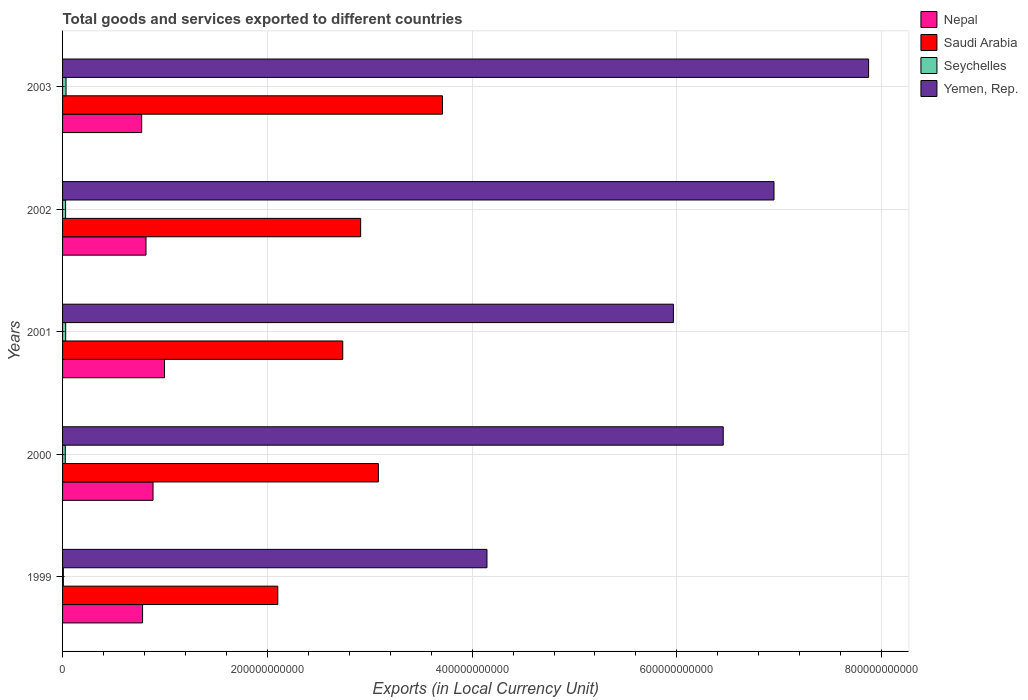Are the number of bars on each tick of the Y-axis equal?
Offer a very short reply. Yes. How many bars are there on the 3rd tick from the top?
Give a very brief answer. 4. In how many cases, is the number of bars for a given year not equal to the number of legend labels?
Keep it short and to the point. 0. What is the Amount of goods and services exports in Seychelles in 2001?
Keep it short and to the point. 3.05e+09. Across all years, what is the maximum Amount of goods and services exports in Seychelles?
Provide a short and direct response. 3.39e+09. Across all years, what is the minimum Amount of goods and services exports in Saudi Arabia?
Give a very brief answer. 2.10e+11. In which year was the Amount of goods and services exports in Saudi Arabia minimum?
Offer a very short reply. 1999. What is the total Amount of goods and services exports in Saudi Arabia in the graph?
Give a very brief answer. 1.45e+12. What is the difference between the Amount of goods and services exports in Saudi Arabia in 2000 and that in 2002?
Ensure brevity in your answer.  1.73e+1. What is the difference between the Amount of goods and services exports in Yemen, Rep. in 1999 and the Amount of goods and services exports in Saudi Arabia in 2003?
Make the answer very short. 4.35e+1. What is the average Amount of goods and services exports in Yemen, Rep. per year?
Your answer should be very brief. 6.28e+11. In the year 1999, what is the difference between the Amount of goods and services exports in Yemen, Rep. and Amount of goods and services exports in Saudi Arabia?
Your answer should be very brief. 2.04e+11. What is the ratio of the Amount of goods and services exports in Yemen, Rep. in 2000 to that in 2003?
Offer a terse response. 0.82. Is the Amount of goods and services exports in Saudi Arabia in 2001 less than that in 2002?
Provide a succinct answer. Yes. What is the difference between the highest and the second highest Amount of goods and services exports in Yemen, Rep.?
Offer a terse response. 9.24e+1. What is the difference between the highest and the lowest Amount of goods and services exports in Yemen, Rep.?
Your answer should be very brief. 3.73e+11. What does the 3rd bar from the top in 2003 represents?
Your answer should be compact. Saudi Arabia. What does the 2nd bar from the bottom in 2002 represents?
Your response must be concise. Saudi Arabia. Is it the case that in every year, the sum of the Amount of goods and services exports in Yemen, Rep. and Amount of goods and services exports in Nepal is greater than the Amount of goods and services exports in Seychelles?
Offer a very short reply. Yes. What is the difference between two consecutive major ticks on the X-axis?
Make the answer very short. 2.00e+11. Does the graph contain grids?
Keep it short and to the point. Yes. How many legend labels are there?
Give a very brief answer. 4. What is the title of the graph?
Your answer should be very brief. Total goods and services exported to different countries. What is the label or title of the X-axis?
Ensure brevity in your answer.  Exports (in Local Currency Unit). What is the Exports (in Local Currency Unit) of Nepal in 1999?
Your answer should be compact. 7.82e+1. What is the Exports (in Local Currency Unit) of Saudi Arabia in 1999?
Make the answer very short. 2.10e+11. What is the Exports (in Local Currency Unit) in Seychelles in 1999?
Provide a short and direct response. 7.75e+08. What is the Exports (in Local Currency Unit) of Yemen, Rep. in 1999?
Offer a very short reply. 4.15e+11. What is the Exports (in Local Currency Unit) in Nepal in 2000?
Keep it short and to the point. 8.84e+1. What is the Exports (in Local Currency Unit) of Saudi Arabia in 2000?
Keep it short and to the point. 3.08e+11. What is the Exports (in Local Currency Unit) of Seychelles in 2000?
Keep it short and to the point. 2.65e+09. What is the Exports (in Local Currency Unit) of Yemen, Rep. in 2000?
Your answer should be very brief. 6.45e+11. What is the Exports (in Local Currency Unit) in Nepal in 2001?
Your response must be concise. 9.96e+1. What is the Exports (in Local Currency Unit) of Saudi Arabia in 2001?
Give a very brief answer. 2.74e+11. What is the Exports (in Local Currency Unit) of Seychelles in 2001?
Your answer should be very brief. 3.05e+09. What is the Exports (in Local Currency Unit) of Yemen, Rep. in 2001?
Your answer should be compact. 5.97e+11. What is the Exports (in Local Currency Unit) of Nepal in 2002?
Ensure brevity in your answer.  8.15e+1. What is the Exports (in Local Currency Unit) in Saudi Arabia in 2002?
Offer a very short reply. 2.91e+11. What is the Exports (in Local Currency Unit) of Seychelles in 2002?
Provide a succinct answer. 2.98e+09. What is the Exports (in Local Currency Unit) in Yemen, Rep. in 2002?
Your answer should be very brief. 6.95e+11. What is the Exports (in Local Currency Unit) in Nepal in 2003?
Your answer should be compact. 7.73e+1. What is the Exports (in Local Currency Unit) of Saudi Arabia in 2003?
Provide a succinct answer. 3.71e+11. What is the Exports (in Local Currency Unit) of Seychelles in 2003?
Provide a succinct answer. 3.39e+09. What is the Exports (in Local Currency Unit) in Yemen, Rep. in 2003?
Offer a terse response. 7.87e+11. Across all years, what is the maximum Exports (in Local Currency Unit) in Nepal?
Your answer should be compact. 9.96e+1. Across all years, what is the maximum Exports (in Local Currency Unit) in Saudi Arabia?
Keep it short and to the point. 3.71e+11. Across all years, what is the maximum Exports (in Local Currency Unit) of Seychelles?
Provide a short and direct response. 3.39e+09. Across all years, what is the maximum Exports (in Local Currency Unit) of Yemen, Rep.?
Ensure brevity in your answer.  7.87e+11. Across all years, what is the minimum Exports (in Local Currency Unit) in Nepal?
Your response must be concise. 7.73e+1. Across all years, what is the minimum Exports (in Local Currency Unit) of Saudi Arabia?
Make the answer very short. 2.10e+11. Across all years, what is the minimum Exports (in Local Currency Unit) in Seychelles?
Your answer should be very brief. 7.75e+08. Across all years, what is the minimum Exports (in Local Currency Unit) of Yemen, Rep.?
Keep it short and to the point. 4.15e+11. What is the total Exports (in Local Currency Unit) of Nepal in the graph?
Give a very brief answer. 4.25e+11. What is the total Exports (in Local Currency Unit) of Saudi Arabia in the graph?
Provide a succinct answer. 1.45e+12. What is the total Exports (in Local Currency Unit) of Seychelles in the graph?
Provide a succinct answer. 1.28e+1. What is the total Exports (in Local Currency Unit) in Yemen, Rep. in the graph?
Your response must be concise. 3.14e+12. What is the difference between the Exports (in Local Currency Unit) of Nepal in 1999 and that in 2000?
Your response must be concise. -1.02e+1. What is the difference between the Exports (in Local Currency Unit) of Saudi Arabia in 1999 and that in 2000?
Your response must be concise. -9.82e+1. What is the difference between the Exports (in Local Currency Unit) in Seychelles in 1999 and that in 2000?
Keep it short and to the point. -1.88e+09. What is the difference between the Exports (in Local Currency Unit) in Yemen, Rep. in 1999 and that in 2000?
Keep it short and to the point. -2.31e+11. What is the difference between the Exports (in Local Currency Unit) in Nepal in 1999 and that in 2001?
Offer a very short reply. -2.14e+1. What is the difference between the Exports (in Local Currency Unit) of Saudi Arabia in 1999 and that in 2001?
Provide a succinct answer. -6.34e+1. What is the difference between the Exports (in Local Currency Unit) in Seychelles in 1999 and that in 2001?
Provide a short and direct response. -2.28e+09. What is the difference between the Exports (in Local Currency Unit) of Yemen, Rep. in 1999 and that in 2001?
Offer a terse response. -1.82e+11. What is the difference between the Exports (in Local Currency Unit) in Nepal in 1999 and that in 2002?
Offer a terse response. -3.34e+09. What is the difference between the Exports (in Local Currency Unit) of Saudi Arabia in 1999 and that in 2002?
Your answer should be very brief. -8.09e+1. What is the difference between the Exports (in Local Currency Unit) of Seychelles in 1999 and that in 2002?
Your answer should be very brief. -2.20e+09. What is the difference between the Exports (in Local Currency Unit) in Yemen, Rep. in 1999 and that in 2002?
Provide a succinct answer. -2.80e+11. What is the difference between the Exports (in Local Currency Unit) in Nepal in 1999 and that in 2003?
Ensure brevity in your answer.  8.70e+08. What is the difference between the Exports (in Local Currency Unit) in Saudi Arabia in 1999 and that in 2003?
Offer a very short reply. -1.61e+11. What is the difference between the Exports (in Local Currency Unit) in Seychelles in 1999 and that in 2003?
Provide a short and direct response. -2.61e+09. What is the difference between the Exports (in Local Currency Unit) in Yemen, Rep. in 1999 and that in 2003?
Your answer should be compact. -3.73e+11. What is the difference between the Exports (in Local Currency Unit) in Nepal in 2000 and that in 2001?
Offer a very short reply. -1.12e+1. What is the difference between the Exports (in Local Currency Unit) in Saudi Arabia in 2000 and that in 2001?
Offer a very short reply. 3.48e+1. What is the difference between the Exports (in Local Currency Unit) in Seychelles in 2000 and that in 2001?
Offer a terse response. -4.03e+08. What is the difference between the Exports (in Local Currency Unit) of Yemen, Rep. in 2000 and that in 2001?
Offer a very short reply. 4.87e+1. What is the difference between the Exports (in Local Currency Unit) of Nepal in 2000 and that in 2002?
Your answer should be compact. 6.87e+09. What is the difference between the Exports (in Local Currency Unit) in Saudi Arabia in 2000 and that in 2002?
Your answer should be compact. 1.73e+1. What is the difference between the Exports (in Local Currency Unit) of Seychelles in 2000 and that in 2002?
Give a very brief answer. -3.25e+08. What is the difference between the Exports (in Local Currency Unit) of Yemen, Rep. in 2000 and that in 2002?
Your answer should be compact. -4.96e+1. What is the difference between the Exports (in Local Currency Unit) in Nepal in 2000 and that in 2003?
Ensure brevity in your answer.  1.11e+1. What is the difference between the Exports (in Local Currency Unit) of Saudi Arabia in 2000 and that in 2003?
Your response must be concise. -6.26e+1. What is the difference between the Exports (in Local Currency Unit) of Seychelles in 2000 and that in 2003?
Offer a terse response. -7.36e+08. What is the difference between the Exports (in Local Currency Unit) of Yemen, Rep. in 2000 and that in 2003?
Keep it short and to the point. -1.42e+11. What is the difference between the Exports (in Local Currency Unit) in Nepal in 2001 and that in 2002?
Give a very brief answer. 1.81e+1. What is the difference between the Exports (in Local Currency Unit) of Saudi Arabia in 2001 and that in 2002?
Keep it short and to the point. -1.75e+1. What is the difference between the Exports (in Local Currency Unit) of Seychelles in 2001 and that in 2002?
Make the answer very short. 7.77e+07. What is the difference between the Exports (in Local Currency Unit) in Yemen, Rep. in 2001 and that in 2002?
Provide a succinct answer. -9.82e+1. What is the difference between the Exports (in Local Currency Unit) of Nepal in 2001 and that in 2003?
Provide a short and direct response. 2.23e+1. What is the difference between the Exports (in Local Currency Unit) of Saudi Arabia in 2001 and that in 2003?
Your answer should be very brief. -9.74e+1. What is the difference between the Exports (in Local Currency Unit) in Seychelles in 2001 and that in 2003?
Your answer should be very brief. -3.34e+08. What is the difference between the Exports (in Local Currency Unit) of Yemen, Rep. in 2001 and that in 2003?
Offer a terse response. -1.91e+11. What is the difference between the Exports (in Local Currency Unit) of Nepal in 2002 and that in 2003?
Your answer should be very brief. 4.21e+09. What is the difference between the Exports (in Local Currency Unit) of Saudi Arabia in 2002 and that in 2003?
Offer a very short reply. -7.99e+1. What is the difference between the Exports (in Local Currency Unit) in Seychelles in 2002 and that in 2003?
Offer a very short reply. -4.11e+08. What is the difference between the Exports (in Local Currency Unit) in Yemen, Rep. in 2002 and that in 2003?
Ensure brevity in your answer.  -9.24e+1. What is the difference between the Exports (in Local Currency Unit) of Nepal in 1999 and the Exports (in Local Currency Unit) of Saudi Arabia in 2000?
Your answer should be compact. -2.30e+11. What is the difference between the Exports (in Local Currency Unit) in Nepal in 1999 and the Exports (in Local Currency Unit) in Seychelles in 2000?
Provide a succinct answer. 7.55e+1. What is the difference between the Exports (in Local Currency Unit) of Nepal in 1999 and the Exports (in Local Currency Unit) of Yemen, Rep. in 2000?
Give a very brief answer. -5.67e+11. What is the difference between the Exports (in Local Currency Unit) of Saudi Arabia in 1999 and the Exports (in Local Currency Unit) of Seychelles in 2000?
Give a very brief answer. 2.08e+11. What is the difference between the Exports (in Local Currency Unit) of Saudi Arabia in 1999 and the Exports (in Local Currency Unit) of Yemen, Rep. in 2000?
Offer a terse response. -4.35e+11. What is the difference between the Exports (in Local Currency Unit) of Seychelles in 1999 and the Exports (in Local Currency Unit) of Yemen, Rep. in 2000?
Give a very brief answer. -6.45e+11. What is the difference between the Exports (in Local Currency Unit) of Nepal in 1999 and the Exports (in Local Currency Unit) of Saudi Arabia in 2001?
Your response must be concise. -1.96e+11. What is the difference between the Exports (in Local Currency Unit) of Nepal in 1999 and the Exports (in Local Currency Unit) of Seychelles in 2001?
Your answer should be very brief. 7.51e+1. What is the difference between the Exports (in Local Currency Unit) of Nepal in 1999 and the Exports (in Local Currency Unit) of Yemen, Rep. in 2001?
Your answer should be very brief. -5.18e+11. What is the difference between the Exports (in Local Currency Unit) of Saudi Arabia in 1999 and the Exports (in Local Currency Unit) of Seychelles in 2001?
Provide a succinct answer. 2.07e+11. What is the difference between the Exports (in Local Currency Unit) of Saudi Arabia in 1999 and the Exports (in Local Currency Unit) of Yemen, Rep. in 2001?
Keep it short and to the point. -3.86e+11. What is the difference between the Exports (in Local Currency Unit) in Seychelles in 1999 and the Exports (in Local Currency Unit) in Yemen, Rep. in 2001?
Your answer should be compact. -5.96e+11. What is the difference between the Exports (in Local Currency Unit) in Nepal in 1999 and the Exports (in Local Currency Unit) in Saudi Arabia in 2002?
Ensure brevity in your answer.  -2.13e+11. What is the difference between the Exports (in Local Currency Unit) in Nepal in 1999 and the Exports (in Local Currency Unit) in Seychelles in 2002?
Offer a very short reply. 7.52e+1. What is the difference between the Exports (in Local Currency Unit) in Nepal in 1999 and the Exports (in Local Currency Unit) in Yemen, Rep. in 2002?
Provide a succinct answer. -6.17e+11. What is the difference between the Exports (in Local Currency Unit) of Saudi Arabia in 1999 and the Exports (in Local Currency Unit) of Seychelles in 2002?
Keep it short and to the point. 2.07e+11. What is the difference between the Exports (in Local Currency Unit) in Saudi Arabia in 1999 and the Exports (in Local Currency Unit) in Yemen, Rep. in 2002?
Ensure brevity in your answer.  -4.85e+11. What is the difference between the Exports (in Local Currency Unit) in Seychelles in 1999 and the Exports (in Local Currency Unit) in Yemen, Rep. in 2002?
Make the answer very short. -6.94e+11. What is the difference between the Exports (in Local Currency Unit) in Nepal in 1999 and the Exports (in Local Currency Unit) in Saudi Arabia in 2003?
Your response must be concise. -2.93e+11. What is the difference between the Exports (in Local Currency Unit) of Nepal in 1999 and the Exports (in Local Currency Unit) of Seychelles in 2003?
Your response must be concise. 7.48e+1. What is the difference between the Exports (in Local Currency Unit) in Nepal in 1999 and the Exports (in Local Currency Unit) in Yemen, Rep. in 2003?
Offer a very short reply. -7.09e+11. What is the difference between the Exports (in Local Currency Unit) of Saudi Arabia in 1999 and the Exports (in Local Currency Unit) of Seychelles in 2003?
Your response must be concise. 2.07e+11. What is the difference between the Exports (in Local Currency Unit) of Saudi Arabia in 1999 and the Exports (in Local Currency Unit) of Yemen, Rep. in 2003?
Offer a very short reply. -5.77e+11. What is the difference between the Exports (in Local Currency Unit) of Seychelles in 1999 and the Exports (in Local Currency Unit) of Yemen, Rep. in 2003?
Provide a succinct answer. -7.87e+11. What is the difference between the Exports (in Local Currency Unit) of Nepal in 2000 and the Exports (in Local Currency Unit) of Saudi Arabia in 2001?
Your answer should be compact. -1.85e+11. What is the difference between the Exports (in Local Currency Unit) of Nepal in 2000 and the Exports (in Local Currency Unit) of Seychelles in 2001?
Provide a succinct answer. 8.53e+1. What is the difference between the Exports (in Local Currency Unit) in Nepal in 2000 and the Exports (in Local Currency Unit) in Yemen, Rep. in 2001?
Your answer should be compact. -5.08e+11. What is the difference between the Exports (in Local Currency Unit) of Saudi Arabia in 2000 and the Exports (in Local Currency Unit) of Seychelles in 2001?
Provide a short and direct response. 3.05e+11. What is the difference between the Exports (in Local Currency Unit) of Saudi Arabia in 2000 and the Exports (in Local Currency Unit) of Yemen, Rep. in 2001?
Your answer should be very brief. -2.88e+11. What is the difference between the Exports (in Local Currency Unit) of Seychelles in 2000 and the Exports (in Local Currency Unit) of Yemen, Rep. in 2001?
Give a very brief answer. -5.94e+11. What is the difference between the Exports (in Local Currency Unit) of Nepal in 2000 and the Exports (in Local Currency Unit) of Saudi Arabia in 2002?
Your response must be concise. -2.03e+11. What is the difference between the Exports (in Local Currency Unit) in Nepal in 2000 and the Exports (in Local Currency Unit) in Seychelles in 2002?
Provide a short and direct response. 8.54e+1. What is the difference between the Exports (in Local Currency Unit) in Nepal in 2000 and the Exports (in Local Currency Unit) in Yemen, Rep. in 2002?
Provide a succinct answer. -6.07e+11. What is the difference between the Exports (in Local Currency Unit) in Saudi Arabia in 2000 and the Exports (in Local Currency Unit) in Seychelles in 2002?
Your answer should be compact. 3.05e+11. What is the difference between the Exports (in Local Currency Unit) of Saudi Arabia in 2000 and the Exports (in Local Currency Unit) of Yemen, Rep. in 2002?
Give a very brief answer. -3.86e+11. What is the difference between the Exports (in Local Currency Unit) of Seychelles in 2000 and the Exports (in Local Currency Unit) of Yemen, Rep. in 2002?
Offer a very short reply. -6.92e+11. What is the difference between the Exports (in Local Currency Unit) of Nepal in 2000 and the Exports (in Local Currency Unit) of Saudi Arabia in 2003?
Provide a succinct answer. -2.83e+11. What is the difference between the Exports (in Local Currency Unit) in Nepal in 2000 and the Exports (in Local Currency Unit) in Seychelles in 2003?
Your answer should be compact. 8.50e+1. What is the difference between the Exports (in Local Currency Unit) in Nepal in 2000 and the Exports (in Local Currency Unit) in Yemen, Rep. in 2003?
Keep it short and to the point. -6.99e+11. What is the difference between the Exports (in Local Currency Unit) in Saudi Arabia in 2000 and the Exports (in Local Currency Unit) in Seychelles in 2003?
Your answer should be very brief. 3.05e+11. What is the difference between the Exports (in Local Currency Unit) of Saudi Arabia in 2000 and the Exports (in Local Currency Unit) of Yemen, Rep. in 2003?
Your answer should be very brief. -4.79e+11. What is the difference between the Exports (in Local Currency Unit) in Seychelles in 2000 and the Exports (in Local Currency Unit) in Yemen, Rep. in 2003?
Your answer should be compact. -7.85e+11. What is the difference between the Exports (in Local Currency Unit) in Nepal in 2001 and the Exports (in Local Currency Unit) in Saudi Arabia in 2002?
Ensure brevity in your answer.  -1.92e+11. What is the difference between the Exports (in Local Currency Unit) of Nepal in 2001 and the Exports (in Local Currency Unit) of Seychelles in 2002?
Your answer should be compact. 9.66e+1. What is the difference between the Exports (in Local Currency Unit) in Nepal in 2001 and the Exports (in Local Currency Unit) in Yemen, Rep. in 2002?
Offer a very short reply. -5.95e+11. What is the difference between the Exports (in Local Currency Unit) in Saudi Arabia in 2001 and the Exports (in Local Currency Unit) in Seychelles in 2002?
Your answer should be compact. 2.71e+11. What is the difference between the Exports (in Local Currency Unit) of Saudi Arabia in 2001 and the Exports (in Local Currency Unit) of Yemen, Rep. in 2002?
Offer a terse response. -4.21e+11. What is the difference between the Exports (in Local Currency Unit) in Seychelles in 2001 and the Exports (in Local Currency Unit) in Yemen, Rep. in 2002?
Ensure brevity in your answer.  -6.92e+11. What is the difference between the Exports (in Local Currency Unit) of Nepal in 2001 and the Exports (in Local Currency Unit) of Saudi Arabia in 2003?
Give a very brief answer. -2.72e+11. What is the difference between the Exports (in Local Currency Unit) in Nepal in 2001 and the Exports (in Local Currency Unit) in Seychelles in 2003?
Offer a terse response. 9.62e+1. What is the difference between the Exports (in Local Currency Unit) in Nepal in 2001 and the Exports (in Local Currency Unit) in Yemen, Rep. in 2003?
Make the answer very short. -6.88e+11. What is the difference between the Exports (in Local Currency Unit) in Saudi Arabia in 2001 and the Exports (in Local Currency Unit) in Seychelles in 2003?
Ensure brevity in your answer.  2.70e+11. What is the difference between the Exports (in Local Currency Unit) of Saudi Arabia in 2001 and the Exports (in Local Currency Unit) of Yemen, Rep. in 2003?
Offer a very short reply. -5.14e+11. What is the difference between the Exports (in Local Currency Unit) of Seychelles in 2001 and the Exports (in Local Currency Unit) of Yemen, Rep. in 2003?
Make the answer very short. -7.84e+11. What is the difference between the Exports (in Local Currency Unit) of Nepal in 2002 and the Exports (in Local Currency Unit) of Saudi Arabia in 2003?
Provide a succinct answer. -2.90e+11. What is the difference between the Exports (in Local Currency Unit) of Nepal in 2002 and the Exports (in Local Currency Unit) of Seychelles in 2003?
Keep it short and to the point. 7.81e+1. What is the difference between the Exports (in Local Currency Unit) of Nepal in 2002 and the Exports (in Local Currency Unit) of Yemen, Rep. in 2003?
Your response must be concise. -7.06e+11. What is the difference between the Exports (in Local Currency Unit) in Saudi Arabia in 2002 and the Exports (in Local Currency Unit) in Seychelles in 2003?
Your response must be concise. 2.88e+11. What is the difference between the Exports (in Local Currency Unit) of Saudi Arabia in 2002 and the Exports (in Local Currency Unit) of Yemen, Rep. in 2003?
Offer a terse response. -4.96e+11. What is the difference between the Exports (in Local Currency Unit) in Seychelles in 2002 and the Exports (in Local Currency Unit) in Yemen, Rep. in 2003?
Make the answer very short. -7.84e+11. What is the average Exports (in Local Currency Unit) of Nepal per year?
Provide a short and direct response. 8.50e+1. What is the average Exports (in Local Currency Unit) in Saudi Arabia per year?
Your answer should be very brief. 2.91e+11. What is the average Exports (in Local Currency Unit) in Seychelles per year?
Your answer should be compact. 2.57e+09. What is the average Exports (in Local Currency Unit) in Yemen, Rep. per year?
Provide a succinct answer. 6.28e+11. In the year 1999, what is the difference between the Exports (in Local Currency Unit) of Nepal and Exports (in Local Currency Unit) of Saudi Arabia?
Your answer should be compact. -1.32e+11. In the year 1999, what is the difference between the Exports (in Local Currency Unit) in Nepal and Exports (in Local Currency Unit) in Seychelles?
Make the answer very short. 7.74e+1. In the year 1999, what is the difference between the Exports (in Local Currency Unit) of Nepal and Exports (in Local Currency Unit) of Yemen, Rep.?
Ensure brevity in your answer.  -3.36e+11. In the year 1999, what is the difference between the Exports (in Local Currency Unit) of Saudi Arabia and Exports (in Local Currency Unit) of Seychelles?
Offer a terse response. 2.09e+11. In the year 1999, what is the difference between the Exports (in Local Currency Unit) in Saudi Arabia and Exports (in Local Currency Unit) in Yemen, Rep.?
Your answer should be compact. -2.04e+11. In the year 1999, what is the difference between the Exports (in Local Currency Unit) of Seychelles and Exports (in Local Currency Unit) of Yemen, Rep.?
Give a very brief answer. -4.14e+11. In the year 2000, what is the difference between the Exports (in Local Currency Unit) of Nepal and Exports (in Local Currency Unit) of Saudi Arabia?
Give a very brief answer. -2.20e+11. In the year 2000, what is the difference between the Exports (in Local Currency Unit) of Nepal and Exports (in Local Currency Unit) of Seychelles?
Provide a short and direct response. 8.57e+1. In the year 2000, what is the difference between the Exports (in Local Currency Unit) in Nepal and Exports (in Local Currency Unit) in Yemen, Rep.?
Your response must be concise. -5.57e+11. In the year 2000, what is the difference between the Exports (in Local Currency Unit) of Saudi Arabia and Exports (in Local Currency Unit) of Seychelles?
Your response must be concise. 3.06e+11. In the year 2000, what is the difference between the Exports (in Local Currency Unit) in Saudi Arabia and Exports (in Local Currency Unit) in Yemen, Rep.?
Your response must be concise. -3.37e+11. In the year 2000, what is the difference between the Exports (in Local Currency Unit) in Seychelles and Exports (in Local Currency Unit) in Yemen, Rep.?
Provide a succinct answer. -6.43e+11. In the year 2001, what is the difference between the Exports (in Local Currency Unit) of Nepal and Exports (in Local Currency Unit) of Saudi Arabia?
Your answer should be very brief. -1.74e+11. In the year 2001, what is the difference between the Exports (in Local Currency Unit) of Nepal and Exports (in Local Currency Unit) of Seychelles?
Your answer should be compact. 9.65e+1. In the year 2001, what is the difference between the Exports (in Local Currency Unit) of Nepal and Exports (in Local Currency Unit) of Yemen, Rep.?
Your response must be concise. -4.97e+11. In the year 2001, what is the difference between the Exports (in Local Currency Unit) of Saudi Arabia and Exports (in Local Currency Unit) of Seychelles?
Make the answer very short. 2.71e+11. In the year 2001, what is the difference between the Exports (in Local Currency Unit) in Saudi Arabia and Exports (in Local Currency Unit) in Yemen, Rep.?
Give a very brief answer. -3.23e+11. In the year 2001, what is the difference between the Exports (in Local Currency Unit) in Seychelles and Exports (in Local Currency Unit) in Yemen, Rep.?
Your answer should be compact. -5.94e+11. In the year 2002, what is the difference between the Exports (in Local Currency Unit) in Nepal and Exports (in Local Currency Unit) in Saudi Arabia?
Offer a very short reply. -2.10e+11. In the year 2002, what is the difference between the Exports (in Local Currency Unit) in Nepal and Exports (in Local Currency Unit) in Seychelles?
Keep it short and to the point. 7.85e+1. In the year 2002, what is the difference between the Exports (in Local Currency Unit) of Nepal and Exports (in Local Currency Unit) of Yemen, Rep.?
Give a very brief answer. -6.13e+11. In the year 2002, what is the difference between the Exports (in Local Currency Unit) of Saudi Arabia and Exports (in Local Currency Unit) of Seychelles?
Your answer should be compact. 2.88e+11. In the year 2002, what is the difference between the Exports (in Local Currency Unit) of Saudi Arabia and Exports (in Local Currency Unit) of Yemen, Rep.?
Your answer should be very brief. -4.04e+11. In the year 2002, what is the difference between the Exports (in Local Currency Unit) in Seychelles and Exports (in Local Currency Unit) in Yemen, Rep.?
Your answer should be compact. -6.92e+11. In the year 2003, what is the difference between the Exports (in Local Currency Unit) in Nepal and Exports (in Local Currency Unit) in Saudi Arabia?
Provide a short and direct response. -2.94e+11. In the year 2003, what is the difference between the Exports (in Local Currency Unit) in Nepal and Exports (in Local Currency Unit) in Seychelles?
Offer a terse response. 7.39e+1. In the year 2003, what is the difference between the Exports (in Local Currency Unit) of Nepal and Exports (in Local Currency Unit) of Yemen, Rep.?
Give a very brief answer. -7.10e+11. In the year 2003, what is the difference between the Exports (in Local Currency Unit) of Saudi Arabia and Exports (in Local Currency Unit) of Seychelles?
Provide a short and direct response. 3.68e+11. In the year 2003, what is the difference between the Exports (in Local Currency Unit) of Saudi Arabia and Exports (in Local Currency Unit) of Yemen, Rep.?
Make the answer very short. -4.16e+11. In the year 2003, what is the difference between the Exports (in Local Currency Unit) of Seychelles and Exports (in Local Currency Unit) of Yemen, Rep.?
Your answer should be very brief. -7.84e+11. What is the ratio of the Exports (in Local Currency Unit) in Nepal in 1999 to that in 2000?
Your answer should be compact. 0.88. What is the ratio of the Exports (in Local Currency Unit) in Saudi Arabia in 1999 to that in 2000?
Offer a terse response. 0.68. What is the ratio of the Exports (in Local Currency Unit) in Seychelles in 1999 to that in 2000?
Keep it short and to the point. 0.29. What is the ratio of the Exports (in Local Currency Unit) in Yemen, Rep. in 1999 to that in 2000?
Offer a terse response. 0.64. What is the ratio of the Exports (in Local Currency Unit) in Nepal in 1999 to that in 2001?
Offer a very short reply. 0.78. What is the ratio of the Exports (in Local Currency Unit) of Saudi Arabia in 1999 to that in 2001?
Provide a short and direct response. 0.77. What is the ratio of the Exports (in Local Currency Unit) in Seychelles in 1999 to that in 2001?
Keep it short and to the point. 0.25. What is the ratio of the Exports (in Local Currency Unit) in Yemen, Rep. in 1999 to that in 2001?
Your response must be concise. 0.69. What is the ratio of the Exports (in Local Currency Unit) of Saudi Arabia in 1999 to that in 2002?
Give a very brief answer. 0.72. What is the ratio of the Exports (in Local Currency Unit) in Seychelles in 1999 to that in 2002?
Provide a succinct answer. 0.26. What is the ratio of the Exports (in Local Currency Unit) of Yemen, Rep. in 1999 to that in 2002?
Make the answer very short. 0.6. What is the ratio of the Exports (in Local Currency Unit) of Nepal in 1999 to that in 2003?
Ensure brevity in your answer.  1.01. What is the ratio of the Exports (in Local Currency Unit) in Saudi Arabia in 1999 to that in 2003?
Give a very brief answer. 0.57. What is the ratio of the Exports (in Local Currency Unit) in Seychelles in 1999 to that in 2003?
Provide a short and direct response. 0.23. What is the ratio of the Exports (in Local Currency Unit) in Yemen, Rep. in 1999 to that in 2003?
Your answer should be very brief. 0.53. What is the ratio of the Exports (in Local Currency Unit) in Nepal in 2000 to that in 2001?
Make the answer very short. 0.89. What is the ratio of the Exports (in Local Currency Unit) of Saudi Arabia in 2000 to that in 2001?
Offer a very short reply. 1.13. What is the ratio of the Exports (in Local Currency Unit) of Seychelles in 2000 to that in 2001?
Give a very brief answer. 0.87. What is the ratio of the Exports (in Local Currency Unit) in Yemen, Rep. in 2000 to that in 2001?
Your response must be concise. 1.08. What is the ratio of the Exports (in Local Currency Unit) of Nepal in 2000 to that in 2002?
Give a very brief answer. 1.08. What is the ratio of the Exports (in Local Currency Unit) in Saudi Arabia in 2000 to that in 2002?
Offer a terse response. 1.06. What is the ratio of the Exports (in Local Currency Unit) of Seychelles in 2000 to that in 2002?
Your answer should be compact. 0.89. What is the ratio of the Exports (in Local Currency Unit) of Nepal in 2000 to that in 2003?
Give a very brief answer. 1.14. What is the ratio of the Exports (in Local Currency Unit) in Saudi Arabia in 2000 to that in 2003?
Your response must be concise. 0.83. What is the ratio of the Exports (in Local Currency Unit) in Seychelles in 2000 to that in 2003?
Provide a succinct answer. 0.78. What is the ratio of the Exports (in Local Currency Unit) of Yemen, Rep. in 2000 to that in 2003?
Keep it short and to the point. 0.82. What is the ratio of the Exports (in Local Currency Unit) of Nepal in 2001 to that in 2002?
Make the answer very short. 1.22. What is the ratio of the Exports (in Local Currency Unit) of Saudi Arabia in 2001 to that in 2002?
Make the answer very short. 0.94. What is the ratio of the Exports (in Local Currency Unit) of Seychelles in 2001 to that in 2002?
Provide a succinct answer. 1.03. What is the ratio of the Exports (in Local Currency Unit) in Yemen, Rep. in 2001 to that in 2002?
Provide a succinct answer. 0.86. What is the ratio of the Exports (in Local Currency Unit) in Nepal in 2001 to that in 2003?
Your answer should be compact. 1.29. What is the ratio of the Exports (in Local Currency Unit) in Saudi Arabia in 2001 to that in 2003?
Keep it short and to the point. 0.74. What is the ratio of the Exports (in Local Currency Unit) of Seychelles in 2001 to that in 2003?
Your answer should be compact. 0.9. What is the ratio of the Exports (in Local Currency Unit) of Yemen, Rep. in 2001 to that in 2003?
Make the answer very short. 0.76. What is the ratio of the Exports (in Local Currency Unit) in Nepal in 2002 to that in 2003?
Make the answer very short. 1.05. What is the ratio of the Exports (in Local Currency Unit) in Saudi Arabia in 2002 to that in 2003?
Offer a terse response. 0.78. What is the ratio of the Exports (in Local Currency Unit) of Seychelles in 2002 to that in 2003?
Provide a short and direct response. 0.88. What is the ratio of the Exports (in Local Currency Unit) of Yemen, Rep. in 2002 to that in 2003?
Your response must be concise. 0.88. What is the difference between the highest and the second highest Exports (in Local Currency Unit) in Nepal?
Your answer should be very brief. 1.12e+1. What is the difference between the highest and the second highest Exports (in Local Currency Unit) of Saudi Arabia?
Offer a terse response. 6.26e+1. What is the difference between the highest and the second highest Exports (in Local Currency Unit) of Seychelles?
Offer a terse response. 3.34e+08. What is the difference between the highest and the second highest Exports (in Local Currency Unit) of Yemen, Rep.?
Your answer should be very brief. 9.24e+1. What is the difference between the highest and the lowest Exports (in Local Currency Unit) of Nepal?
Offer a terse response. 2.23e+1. What is the difference between the highest and the lowest Exports (in Local Currency Unit) of Saudi Arabia?
Offer a very short reply. 1.61e+11. What is the difference between the highest and the lowest Exports (in Local Currency Unit) in Seychelles?
Give a very brief answer. 2.61e+09. What is the difference between the highest and the lowest Exports (in Local Currency Unit) of Yemen, Rep.?
Give a very brief answer. 3.73e+11. 